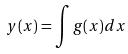<formula> <loc_0><loc_0><loc_500><loc_500>y ( x ) = \int g ( x ) d x</formula> 